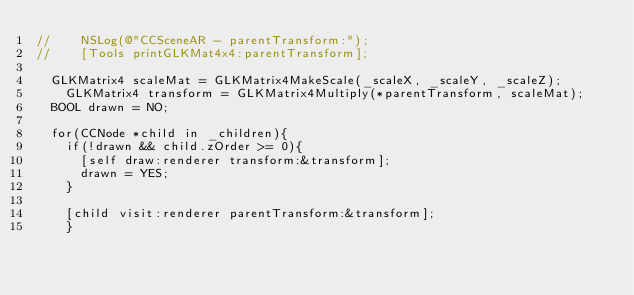Convert code to text. <code><loc_0><loc_0><loc_500><loc_500><_ObjectiveC_>//    NSLog(@"CCSceneAR - parentTransform:");
//    [Tools printGLKMat4x4:parentTransform];
    
	GLKMatrix4 scaleMat = GLKMatrix4MakeScale(_scaleX, _scaleY, _scaleZ);
    GLKMatrix4 transform = GLKMatrix4Multiply(*parentTransform, scaleMat);
	BOOL drawn = NO;
    
	for(CCNode *child in _children){
		if(!drawn && child.zOrder >= 0){
			[self draw:renderer transform:&transform];
			drawn = YES;
		}
        
		[child visit:renderer parentTransform:&transform];
    }
    </code> 